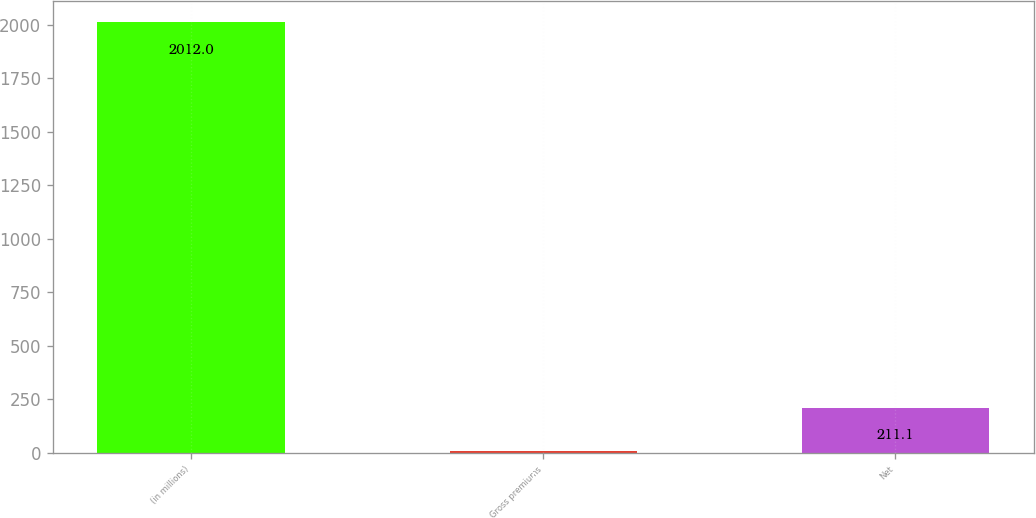Convert chart. <chart><loc_0><loc_0><loc_500><loc_500><bar_chart><fcel>(in millions)<fcel>Gross premiums<fcel>Net<nl><fcel>2012<fcel>11<fcel>211.1<nl></chart> 